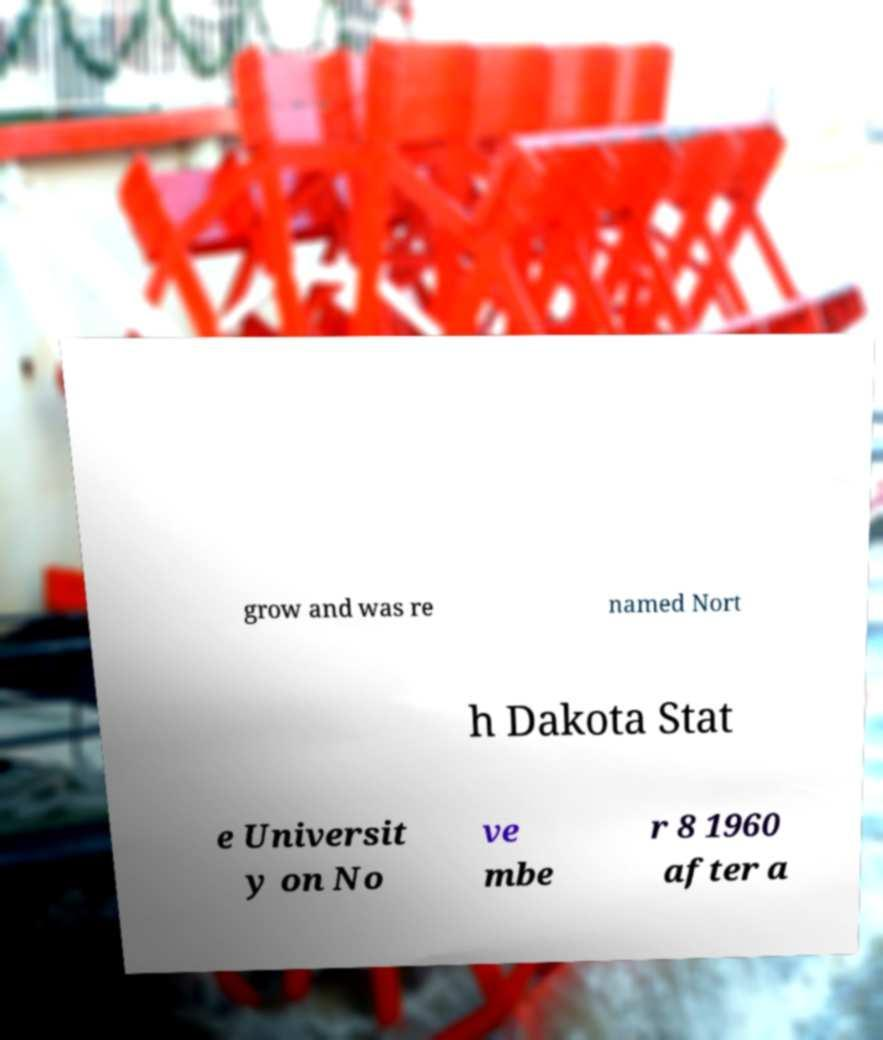Please read and relay the text visible in this image. What does it say? grow and was re named Nort h Dakota Stat e Universit y on No ve mbe r 8 1960 after a 